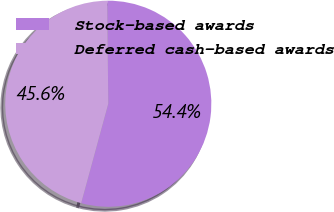Convert chart. <chart><loc_0><loc_0><loc_500><loc_500><pie_chart><fcel>Stock-based awards<fcel>Deferred cash-based awards<nl><fcel>54.4%<fcel>45.6%<nl></chart> 